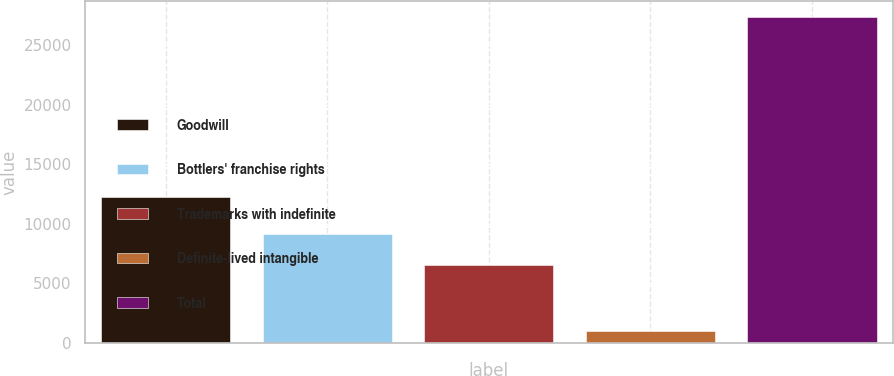Convert chart to OTSL. <chart><loc_0><loc_0><loc_500><loc_500><bar_chart><fcel>Goodwill<fcel>Bottlers' franchise rights<fcel>Trademarks with indefinite<fcel>Definite-lived intangible<fcel>Total<nl><fcel>12255<fcel>9156.8<fcel>6527<fcel>1039<fcel>27337<nl></chart> 